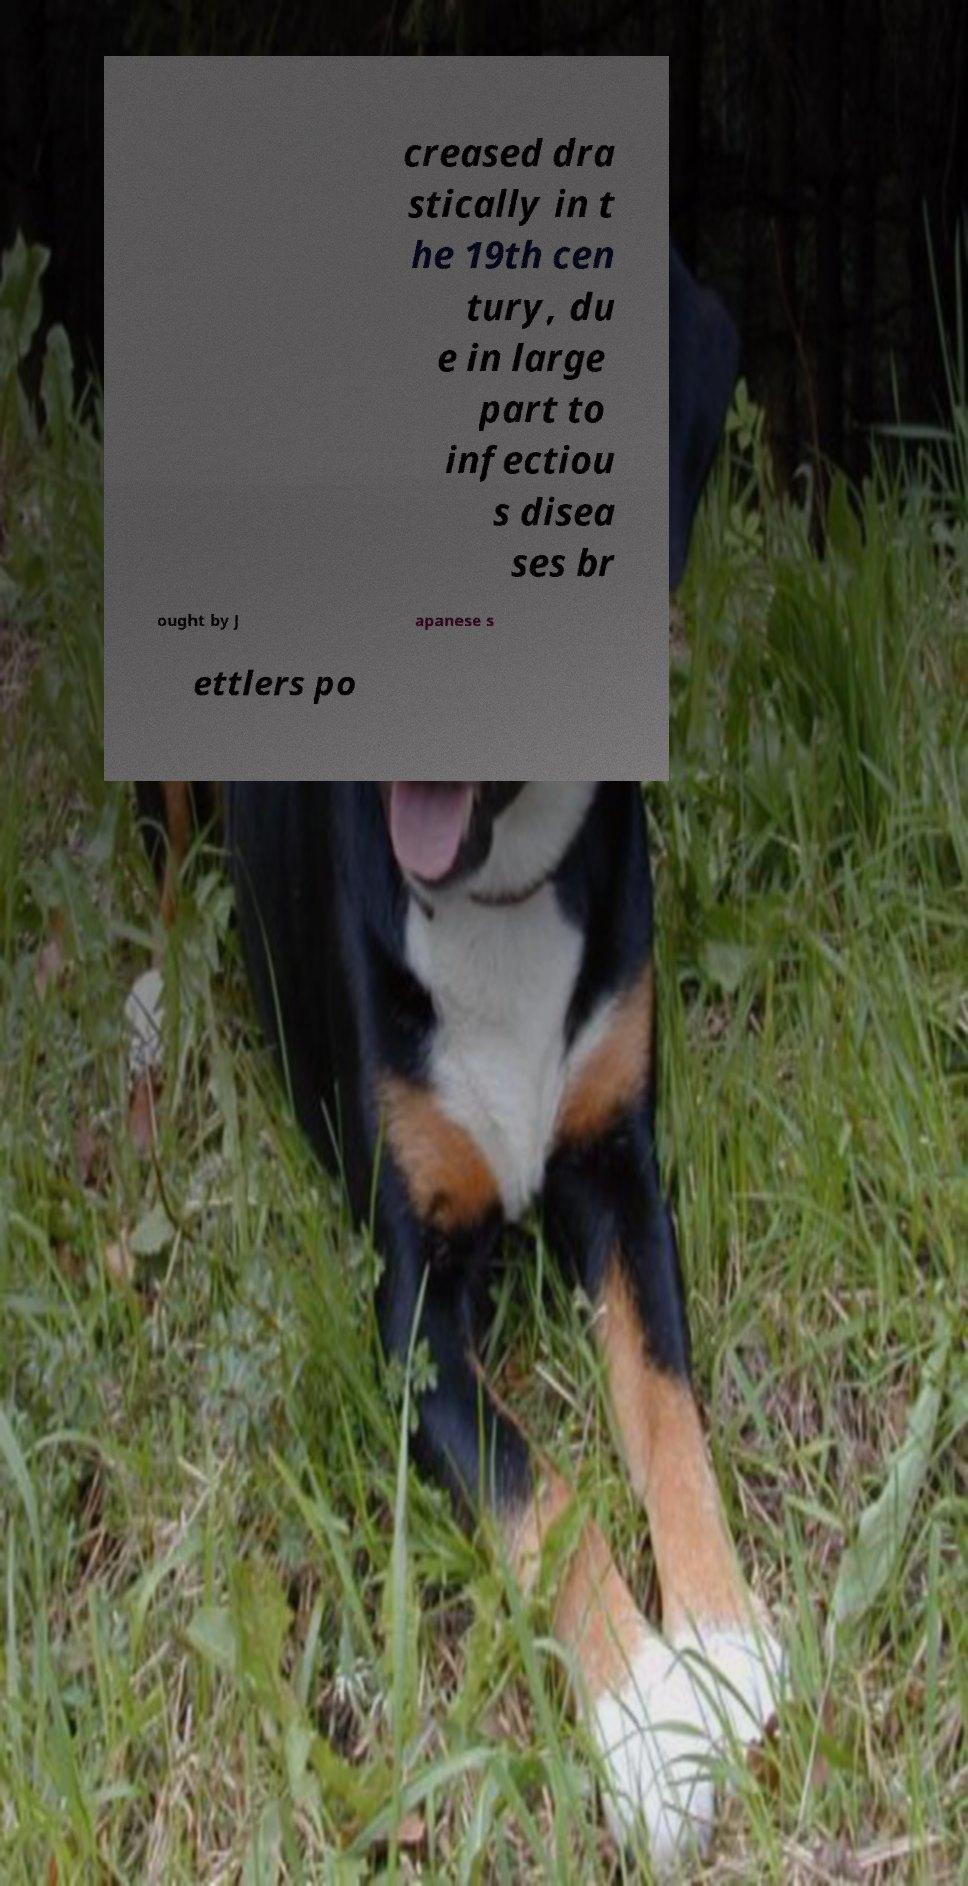Please read and relay the text visible in this image. What does it say? creased dra stically in t he 19th cen tury, du e in large part to infectiou s disea ses br ought by J apanese s ettlers po 